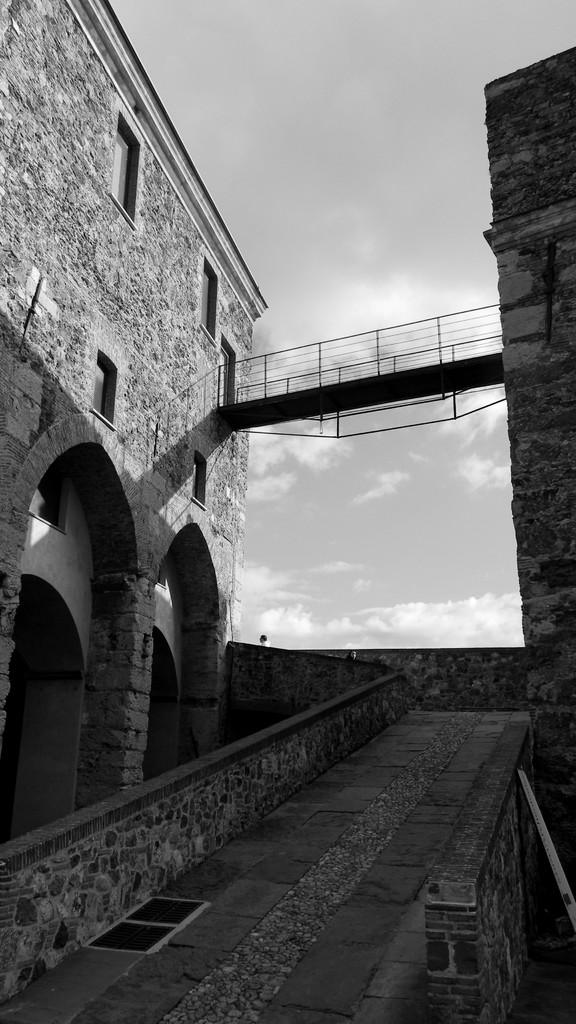What type of structure is present in the image? There is a building in the image. What can be seen in the background of the image? The sky is visible in the background of the image. Who is the creator of the lead cattle in the image? There is no lead cattle or creator mentioned in the image, as it only features a building and the sky. 